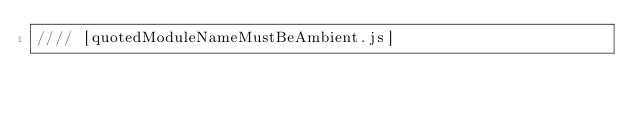<code> <loc_0><loc_0><loc_500><loc_500><_JavaScript_>//// [quotedModuleNameMustBeAmbient.js]
</code> 